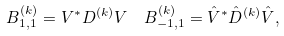<formula> <loc_0><loc_0><loc_500><loc_500>B ^ { ( k ) } _ { 1 , 1 } & = V ^ { * } D ^ { ( k ) } V \quad B ^ { ( k ) } _ { - 1 , 1 } = \hat { V } ^ { * } \hat { D } ^ { ( k ) } \hat { V } ,</formula> 